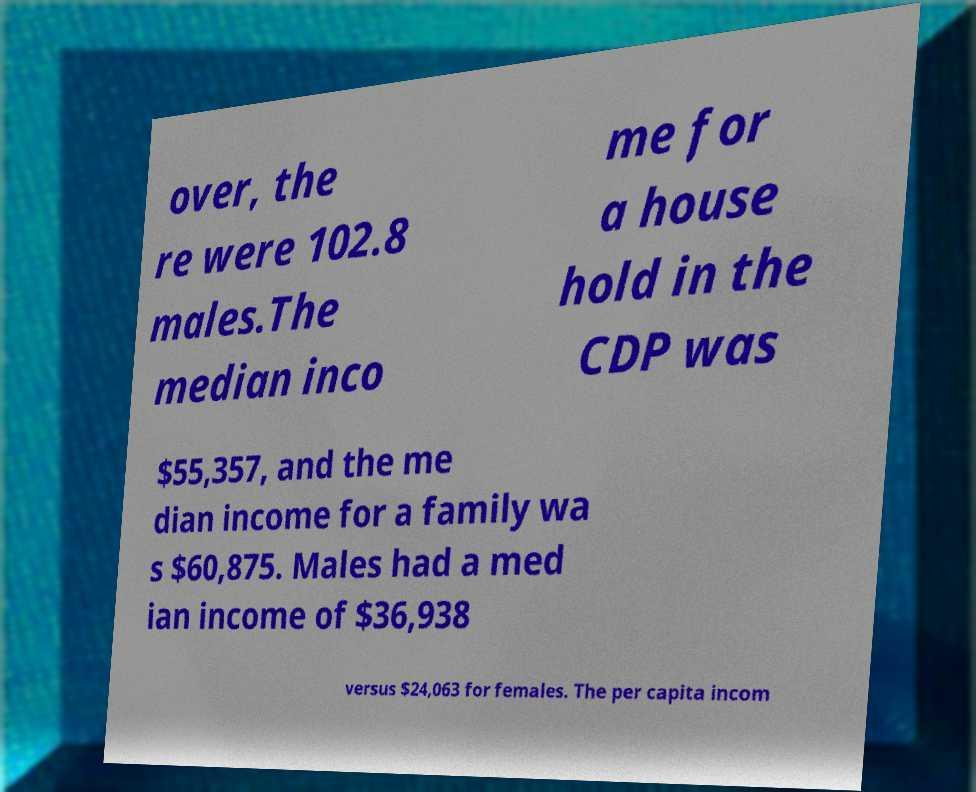I need the written content from this picture converted into text. Can you do that? over, the re were 102.8 males.The median inco me for a house hold in the CDP was $55,357, and the me dian income for a family wa s $60,875. Males had a med ian income of $36,938 versus $24,063 for females. The per capita incom 